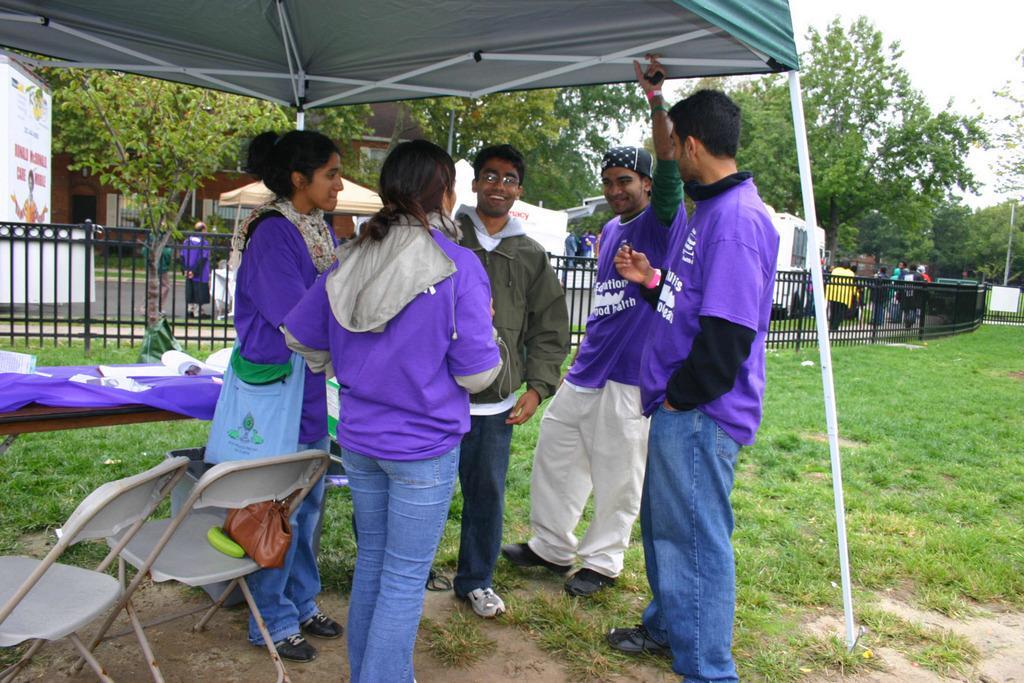Can you describe this image briefly? In this picture there are five members standing. Three of them were men and two of them were women. There are two white color chairs on the left side. All of them were smiling. There is a black color railing and we can observe some grass on the ground. They are standing under the tent. In the background there are trees and a sky. 